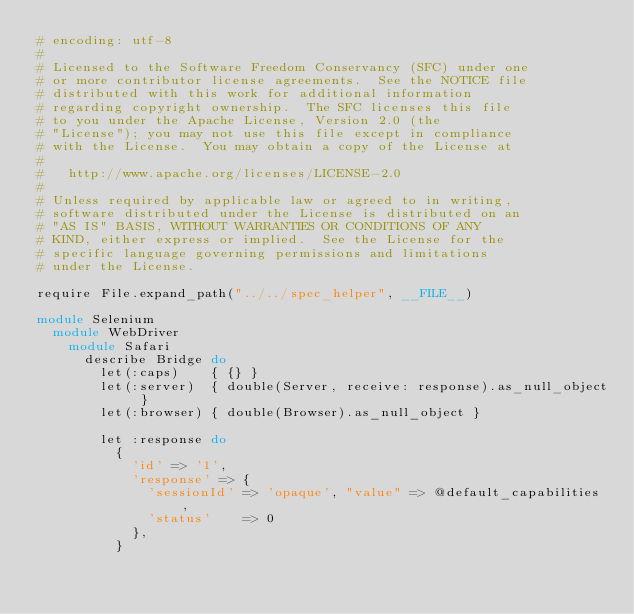<code> <loc_0><loc_0><loc_500><loc_500><_Ruby_># encoding: utf-8
#
# Licensed to the Software Freedom Conservancy (SFC) under one
# or more contributor license agreements.  See the NOTICE file
# distributed with this work for additional information
# regarding copyright ownership.  The SFC licenses this file
# to you under the Apache License, Version 2.0 (the
# "License"); you may not use this file except in compliance
# with the License.  You may obtain a copy of the License at
#
#   http://www.apache.org/licenses/LICENSE-2.0
#
# Unless required by applicable law or agreed to in writing,
# software distributed under the License is distributed on an
# "AS IS" BASIS, WITHOUT WARRANTIES OR CONDITIONS OF ANY
# KIND, either express or implied.  See the License for the
# specific language governing permissions and limitations
# under the License.

require File.expand_path("../../spec_helper", __FILE__)

module Selenium
  module WebDriver
    module Safari
      describe Bridge do
        let(:caps)    { {} }
        let(:server)  { double(Server, receive: response).as_null_object }
        let(:browser) { double(Browser).as_null_object }

        let :response do
          {
            'id' => '1',
            'response' => {
              'sessionId' => 'opaque', "value" => @default_capabilities ,
              'status'    => 0
            },
          }</code> 